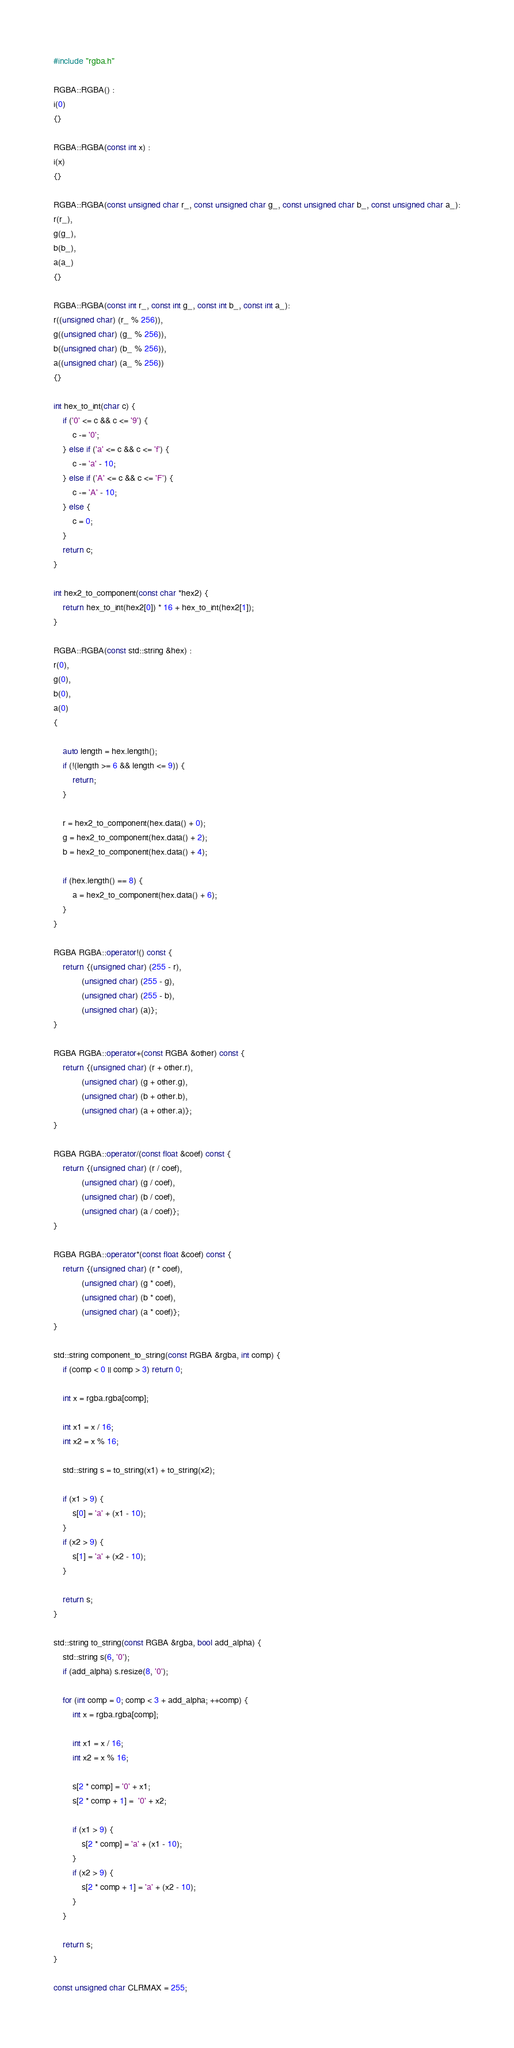<code> <loc_0><loc_0><loc_500><loc_500><_C++_>#include "rgba.h"

RGBA::RGBA() :
i(0)
{}

RGBA::RGBA(const int x) :
i(x)
{}

RGBA::RGBA(const unsigned char r_, const unsigned char g_, const unsigned char b_, const unsigned char a_):
r(r_),
g(g_),
b(b_),
a(a_)
{}

RGBA::RGBA(const int r_, const int g_, const int b_, const int a_):
r((unsigned char) (r_ % 256)),
g((unsigned char) (g_ % 256)),
b((unsigned char) (b_ % 256)),
a((unsigned char) (a_ % 256))
{}

int hex_to_int(char c) {
    if ('0' <= c && c <= '9') {
        c -= '0';
    } else if ('a' <= c && c <= 'f') {
        c -= 'a' - 10;
    } else if ('A' <= c && c <= 'F') {
        c -= 'A' - 10;
    } else {
        c = 0;
    }
    return c;
}

int hex2_to_component(const char *hex2) {
    return hex_to_int(hex2[0]) * 16 + hex_to_int(hex2[1]);
}

RGBA::RGBA(const std::string &hex) :
r(0),
g(0),
b(0),
a(0)
{
    
    auto length = hex.length();
    if (!(length >= 6 && length <= 9)) {
        return;
    }

    r = hex2_to_component(hex.data() + 0);
    g = hex2_to_component(hex.data() + 2);
    b = hex2_to_component(hex.data() + 4);

    if (hex.length() == 8) {
        a = hex2_to_component(hex.data() + 6);
    }
}

RGBA RGBA::operator!() const {
    return {(unsigned char) (255 - r),
            (unsigned char) (255 - g),
            (unsigned char) (255 - b),
            (unsigned char) (a)};
}

RGBA RGBA::operator+(const RGBA &other) const {
    return {(unsigned char) (r + other.r),
            (unsigned char) (g + other.g),
            (unsigned char) (b + other.b),
            (unsigned char) (a + other.a)};
}

RGBA RGBA::operator/(const float &coef) const {
    return {(unsigned char) (r / coef),
            (unsigned char) (g / coef),
            (unsigned char) (b / coef),
            (unsigned char) (a / coef)};
}

RGBA RGBA::operator*(const float &coef) const {
    return {(unsigned char) (r * coef),
            (unsigned char) (g * coef),
            (unsigned char) (b * coef),
            (unsigned char) (a * coef)};
}

std::string component_to_string(const RGBA &rgba, int comp) {
    if (comp < 0 || comp > 3) return 0;

    int x = rgba.rgba[comp];
    
    int x1 = x / 16;
    int x2 = x % 16;

    std::string s = to_string(x1) + to_string(x2);

    if (x1 > 9) {
        s[0] = 'a' + (x1 - 10);
    }
    if (x2 > 9) {
        s[1] = 'a' + (x2 - 10);
    }

    return s;
}

std::string to_string(const RGBA &rgba, bool add_alpha) {
    std::string s(6, '0');
    if (add_alpha) s.resize(8, '0');

    for (int comp = 0; comp < 3 + add_alpha; ++comp) {
        int x = rgba.rgba[comp];
    
        int x1 = x / 16;
        int x2 = x % 16;

        s[2 * comp] = '0' + x1;
        s[2 * comp + 1] =  '0' + x2;

        if (x1 > 9) {
            s[2 * comp] = 'a' + (x1 - 10);
        }
        if (x2 > 9) {
            s[2 * comp + 1] = 'a' + (x2 - 10);
        }
    }

    return s;
}

const unsigned char CLRMAX = 255;
</code> 